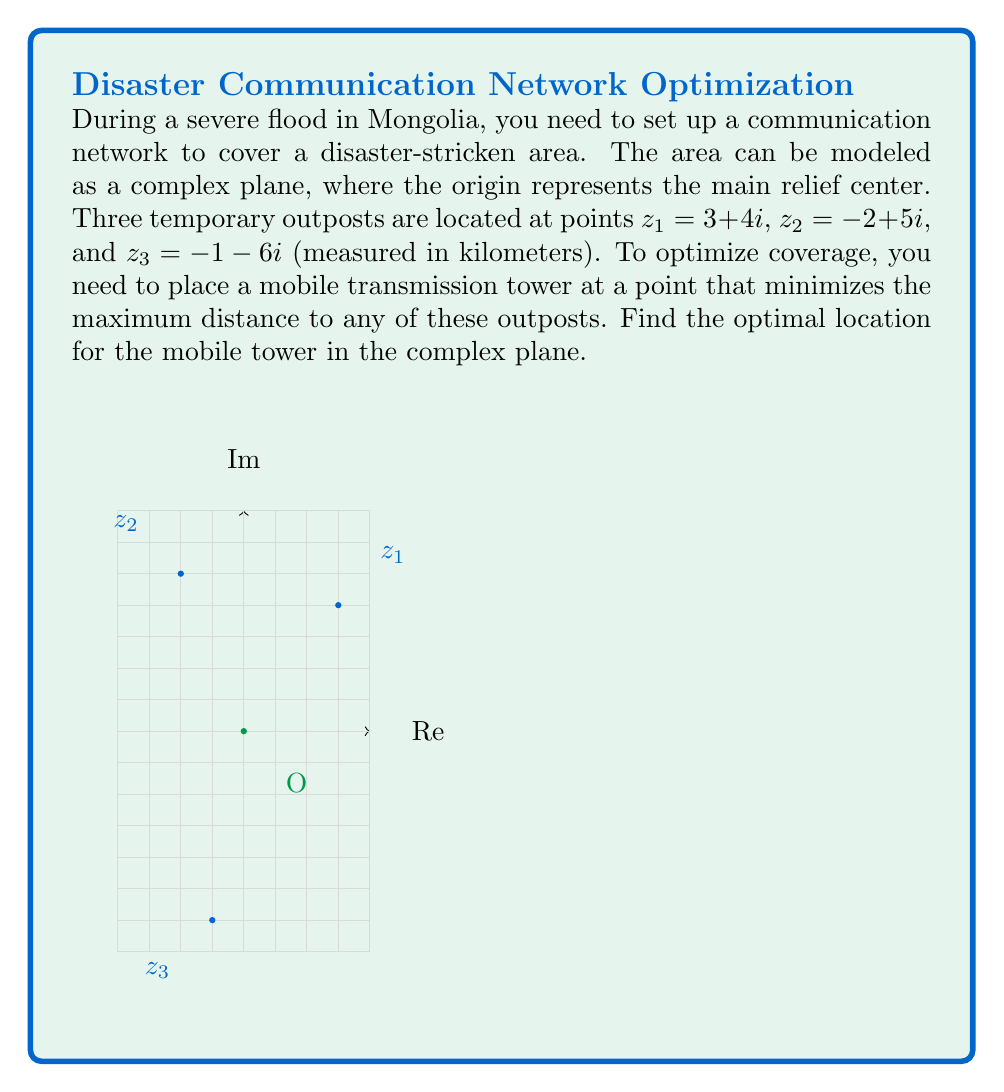Teach me how to tackle this problem. To solve this problem, we need to find the circumcenter of the triangle formed by the three outposts. The circumcenter is equidistant from all three points and thus minimizes the maximum distance to any point.

Step 1: Calculate the perpendicular bisectors of two sides of the triangle.

Let's find the perpendicular bisectors of $\overline{z_1z_2}$ and $\overline{z_1z_3}$.

For $\overline{z_1z_2}$:
Midpoint: $m_1 = \frac{z_1 + z_2}{2} = \frac{(3+4i) + (-2+5i)}{2} = \frac{1+9i}{2} = 0.5 + 4.5i$
Perpendicular vector: $v_1 = i(z_2 - z_1) = i(-5+i) = 1+5i$

For $\overline{z_1z_3}$:
Midpoint: $m_2 = \frac{z_1 + z_3}{2} = \frac{(3+4i) + (-1-6i)}{2} = \frac{2-2i}{2} = 1-i$
Perpendicular vector: $v_2 = i(z_3 - z_1) = i(-4-10i) = 10-4i$

Step 2: Find the intersection of the perpendicular bisectors.

The circumcenter $z$ satisfies:
$z = m_1 + t_1v_1 = m_2 + t_2v_2$ for some real $t_1$ and $t_2$.

Equating the real and imaginary parts:
$0.5 + t_1 = 1 + 10t_2$
$4.5 + 5t_1 = -1 - 4t_2$

Solving this system of equations:
$t_1 = \frac{11}{14}$, $t_2 = \frac{1}{14}$

Step 3: Calculate the circumcenter.

$z = m_1 + t_1v_1 = (0.5 + 4.5i) + \frac{11}{14}(1+5i) = \frac{7+63i}{14} + \frac{11+55i}{14} = \frac{18+118i}{14} = \frac{9+59i}{7}$

Therefore, the optimal location for the mobile tower is $\frac{9+59i}{7} \approx 1.29 + 8.43i$ kilometers from the main relief center.
Answer: $\frac{9+59i}{7}$ 